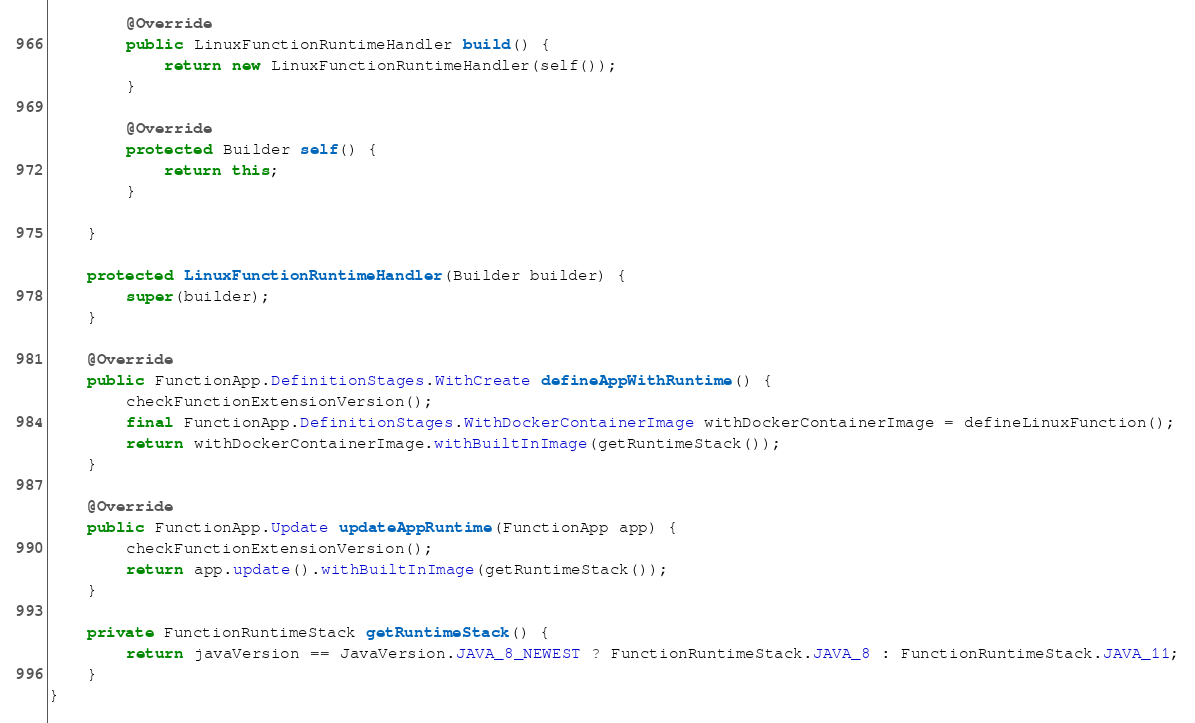<code> <loc_0><loc_0><loc_500><loc_500><_Java_>        @Override
        public LinuxFunctionRuntimeHandler build() {
            return new LinuxFunctionRuntimeHandler(self());
        }

        @Override
        protected Builder self() {
            return this;
        }

    }

    protected LinuxFunctionRuntimeHandler(Builder builder) {
        super(builder);
    }

    @Override
    public FunctionApp.DefinitionStages.WithCreate defineAppWithRuntime() {
        checkFunctionExtensionVersion();
        final FunctionApp.DefinitionStages.WithDockerContainerImage withDockerContainerImage = defineLinuxFunction();
        return withDockerContainerImage.withBuiltInImage(getRuntimeStack());
    }

    @Override
    public FunctionApp.Update updateAppRuntime(FunctionApp app) {
        checkFunctionExtensionVersion();
        return app.update().withBuiltInImage(getRuntimeStack());
    }

    private FunctionRuntimeStack getRuntimeStack() {
        return javaVersion == JavaVersion.JAVA_8_NEWEST ? FunctionRuntimeStack.JAVA_8 : FunctionRuntimeStack.JAVA_11;
    }
}
</code> 